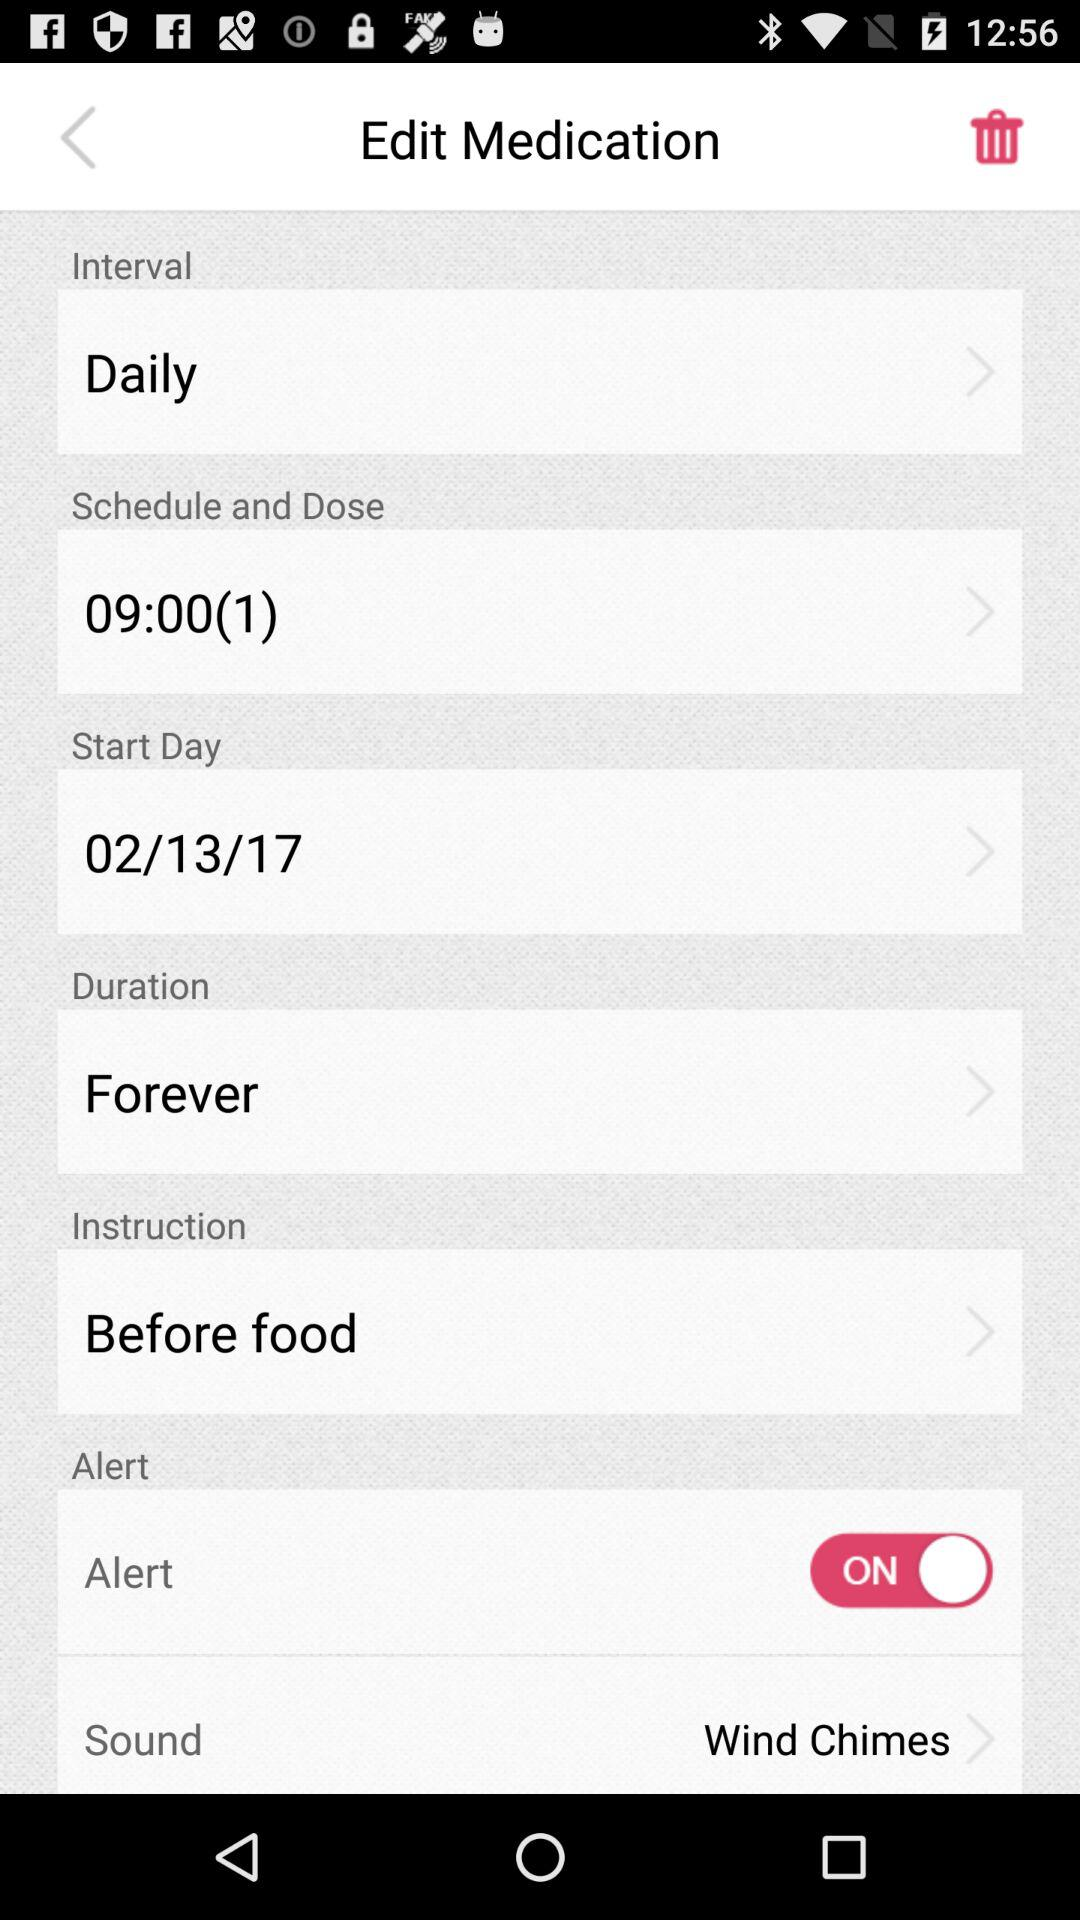What's the status of "Alert"? The status is "ON". 